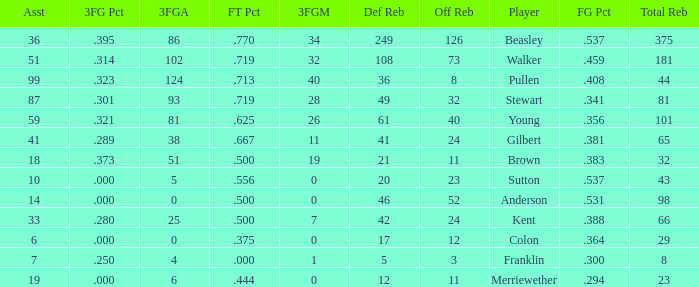How many offensive rebounds do players with fewer than 65 total rebounds, 5 defensive rebounds, and less than 7 assists have in total? 0.0. 